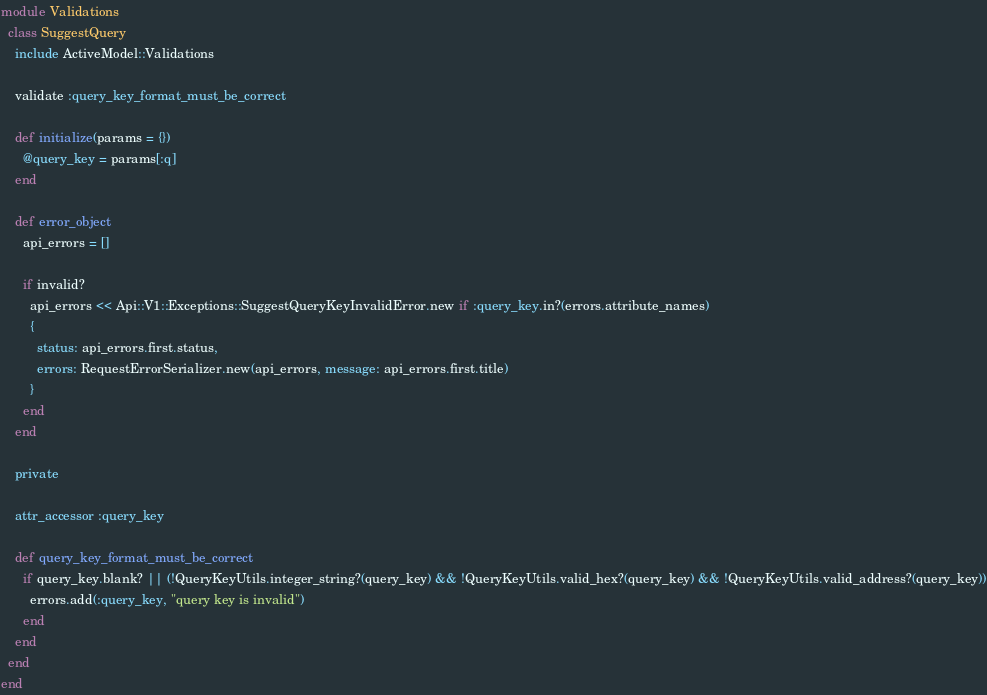Convert code to text. <code><loc_0><loc_0><loc_500><loc_500><_Ruby_>module Validations
  class SuggestQuery
    include ActiveModel::Validations

    validate :query_key_format_must_be_correct

    def initialize(params = {})
      @query_key = params[:q]
    end

    def error_object
      api_errors = []

      if invalid?
        api_errors << Api::V1::Exceptions::SuggestQueryKeyInvalidError.new if :query_key.in?(errors.attribute_names)
        {
          status: api_errors.first.status,
          errors: RequestErrorSerializer.new(api_errors, message: api_errors.first.title)
        }
      end
    end

    private

    attr_accessor :query_key

    def query_key_format_must_be_correct
      if query_key.blank? || (!QueryKeyUtils.integer_string?(query_key) && !QueryKeyUtils.valid_hex?(query_key) && !QueryKeyUtils.valid_address?(query_key))
        errors.add(:query_key, "query key is invalid")
      end
    end
  end
end
</code> 